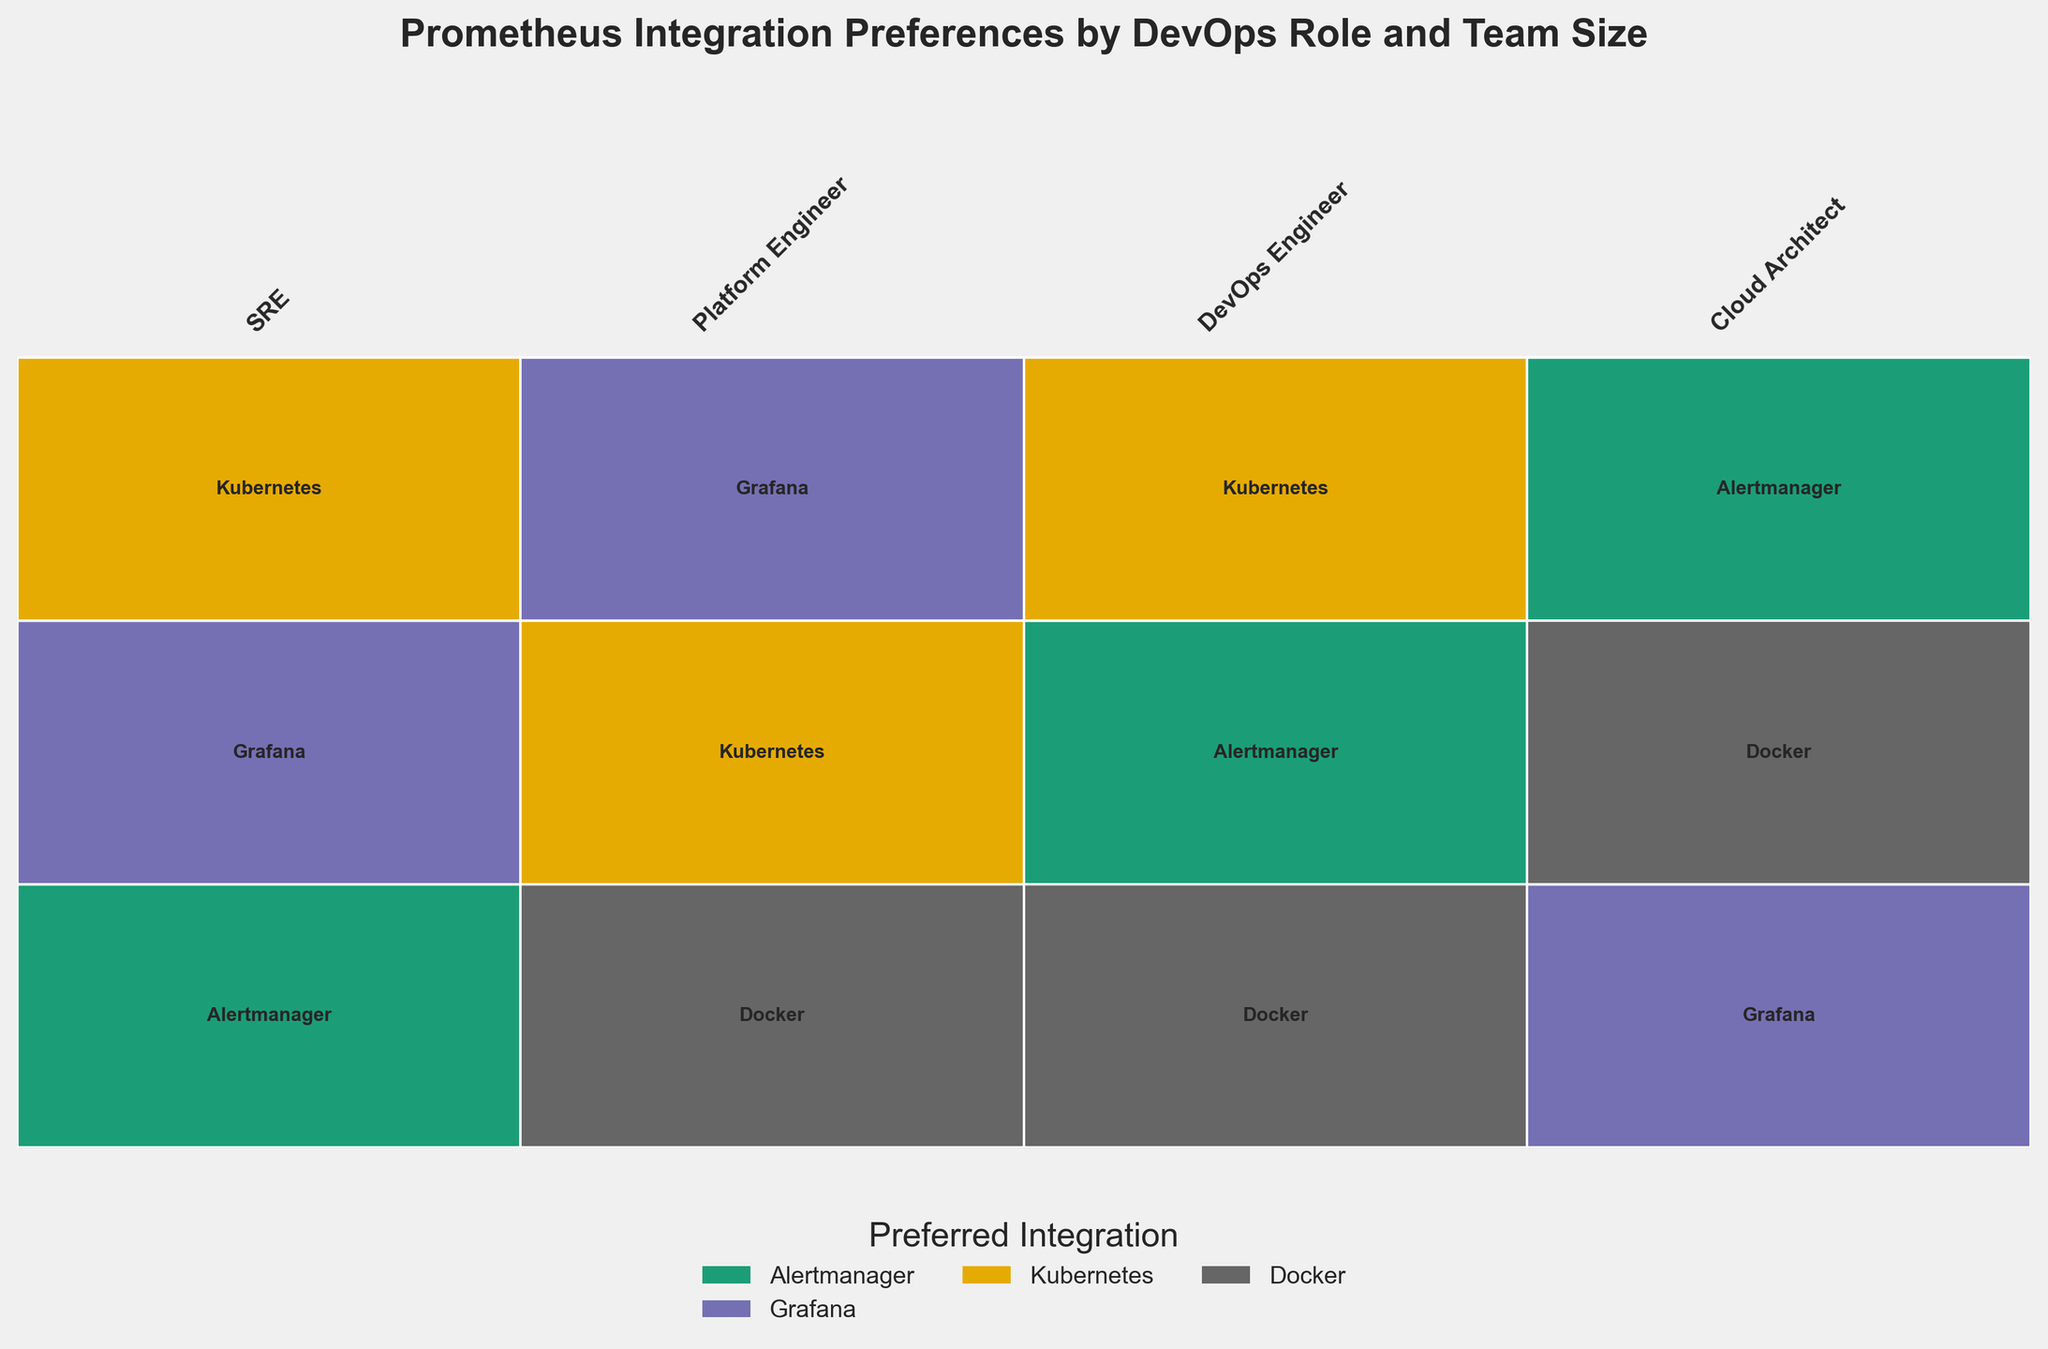What is the title of the plot? The title of the plot is displayed prominently at the top and reads: 'Prometheus Integration Preferences by DevOps Role and Team Size'
Answer: 'Prometheus Integration Preferences by DevOps Role and Team Size' Which DevOps role has the largest width on the mosaic plot? The width of each role is proportional to its representation in the dataset. The role occupying the largest width in the plot appears to be 'SRE'
Answer: SRE How many preferred integrations are represented by different colors in the plot? The legend at the bottom of the plot shows distinct colors representing different integrations. Counting these colors reveals a total of four integrations: Alertmanager, Grafana, Kubernetes, Docker
Answer: Four Which integration is preferred by large teams for 'SRE'? According to the plot, for 'SRE' under the large team size, the color representing Kubernetes is predominant
Answer: Kubernetes Among the medium teams, which DevOps role prefers Docker integration? By inspecting the mosaic plot, the medium-sized teams for 'Cloud Architect' show a preference for Docker, represented by the respective color
Answer: Cloud Architect 